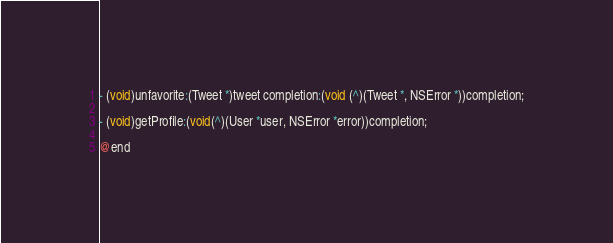<code> <loc_0><loc_0><loc_500><loc_500><_C_>
- (void)unfavorite:(Tweet *)tweet completion:(void (^)(Tweet *, NSError *))completion;

- (void)getProfile:(void(^)(User *user, NSError *error))completion;

@end
</code> 